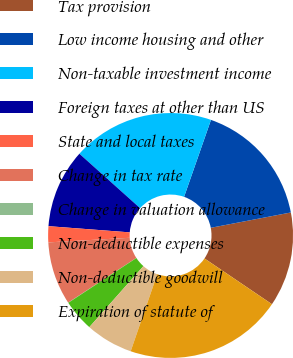<chart> <loc_0><loc_0><loc_500><loc_500><pie_chart><fcel>Tax provision<fcel>Low income housing and other<fcel>Non-taxable investment income<fcel>Foreign taxes at other than US<fcel>State and local taxes<fcel>Change in tax rate<fcel>Change in valuation allowance<fcel>Non-deductible expenses<fcel>Non-deductible goodwill<fcel>Expiration of statute of<nl><fcel>12.49%<fcel>16.64%<fcel>18.72%<fcel>10.42%<fcel>2.11%<fcel>8.34%<fcel>0.03%<fcel>4.19%<fcel>6.26%<fcel>20.8%<nl></chart> 